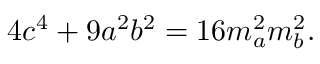Convert formula to latex. <formula><loc_0><loc_0><loc_500><loc_500>4 c ^ { 4 } + 9 a ^ { 2 } b ^ { 2 } = 1 6 m _ { a } ^ { 2 } m _ { b } ^ { 2 } .</formula> 